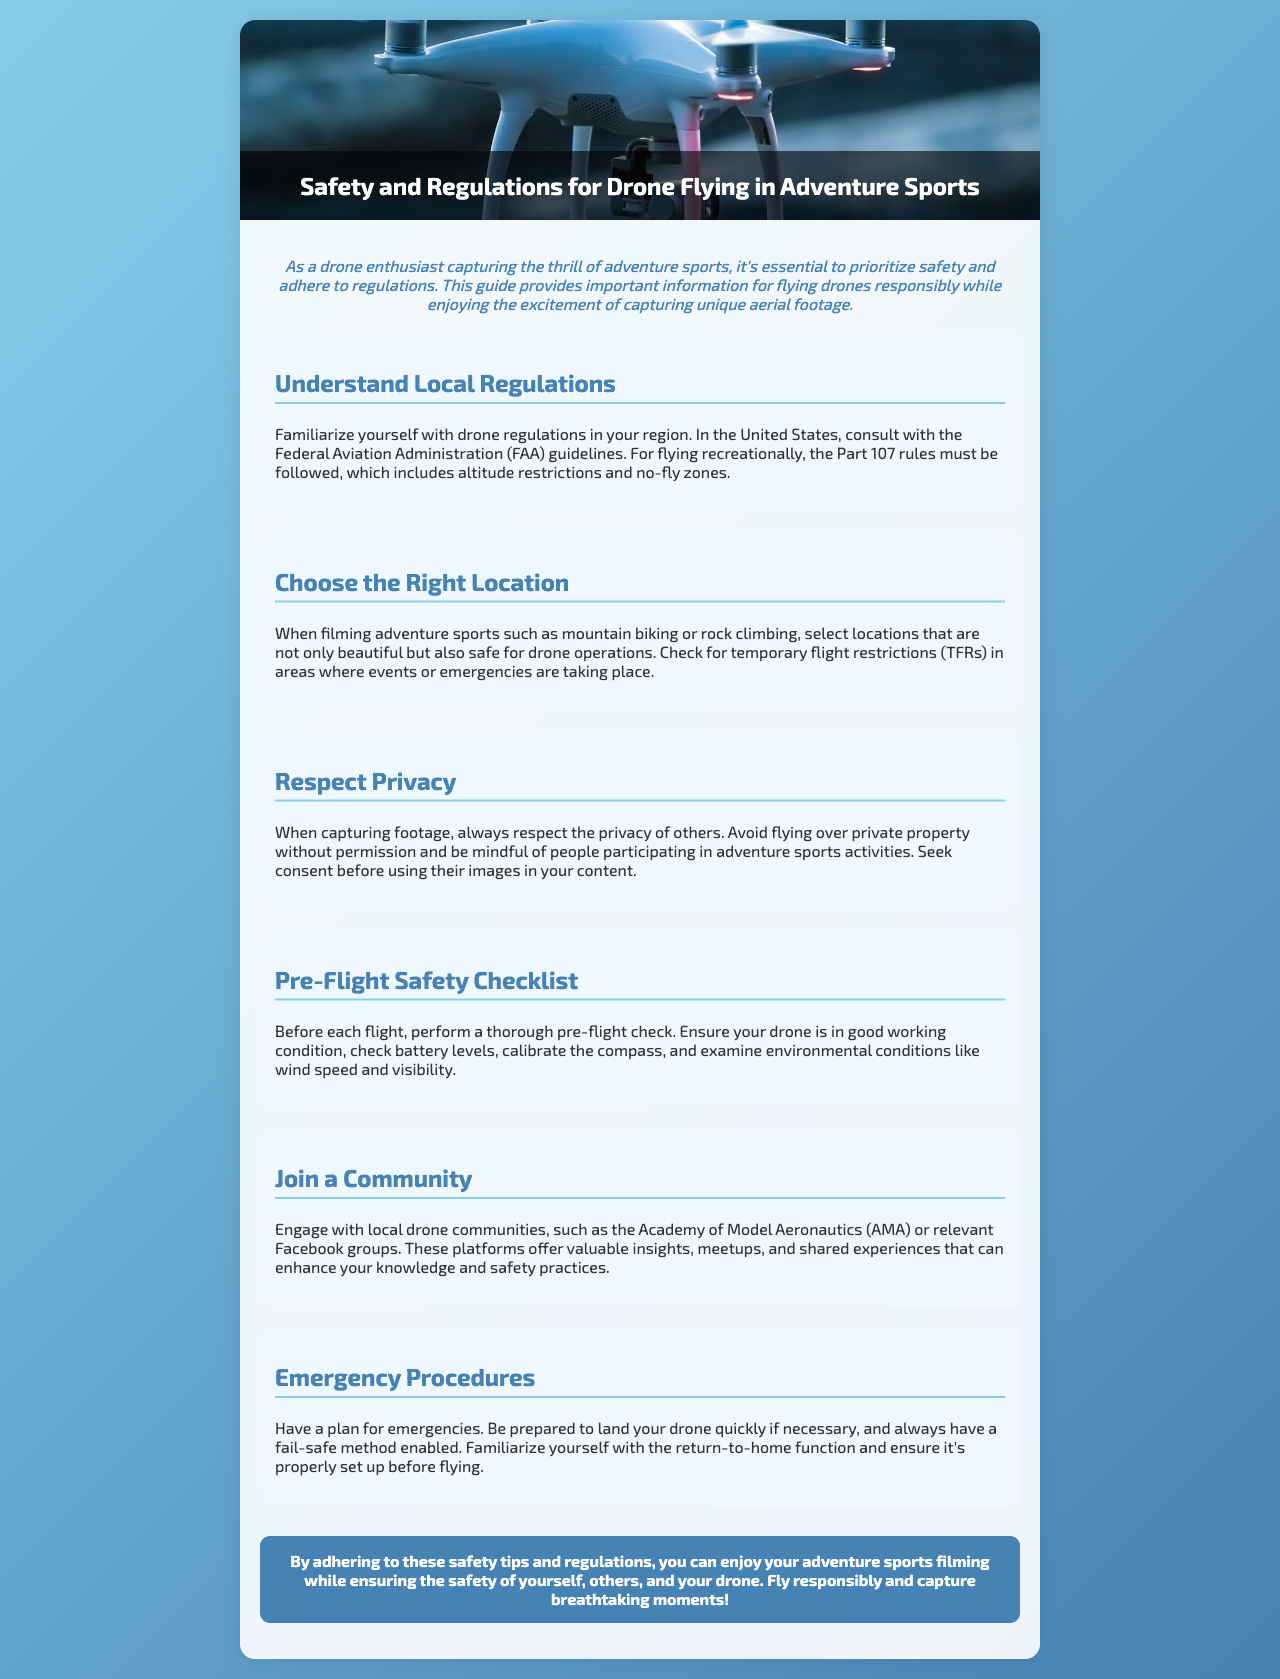What are the FAA guidelines? The FAA guidelines are the regulations provided by the Federal Aviation Administration in the United States for drone operations.
Answer: FAA guidelines What must be followed for recreational flying? The Part 107 rules must be followed for recreational flying, which includes specific regulations like altitude restrictions.
Answer: Part 107 rules What should be checked for temporary flight restrictions? Temporary flight restrictions (TFRs) should be checked in areas where events or emergencies are taking place.
Answer: TFRs What should be done before each flight? A thorough pre-flight check should be performed before each flight.
Answer: Pre-flight check Which organizations offer local drone community insights? The Academy of Model Aeronautics (AMA) offers local drone community insights.
Answer: Academy of Model Aeronautics What is the conclusion about drone safety practices? The conclusion emphasizes adhering to safety tips and regulations to ensure responsible flying and capturing of moments.
Answer: Fly responsibly What is a critical component of emergency procedures? Familiarizing yourself with the return-to-home function is a critical component of emergency procedures.
Answer: Return-to-home function 